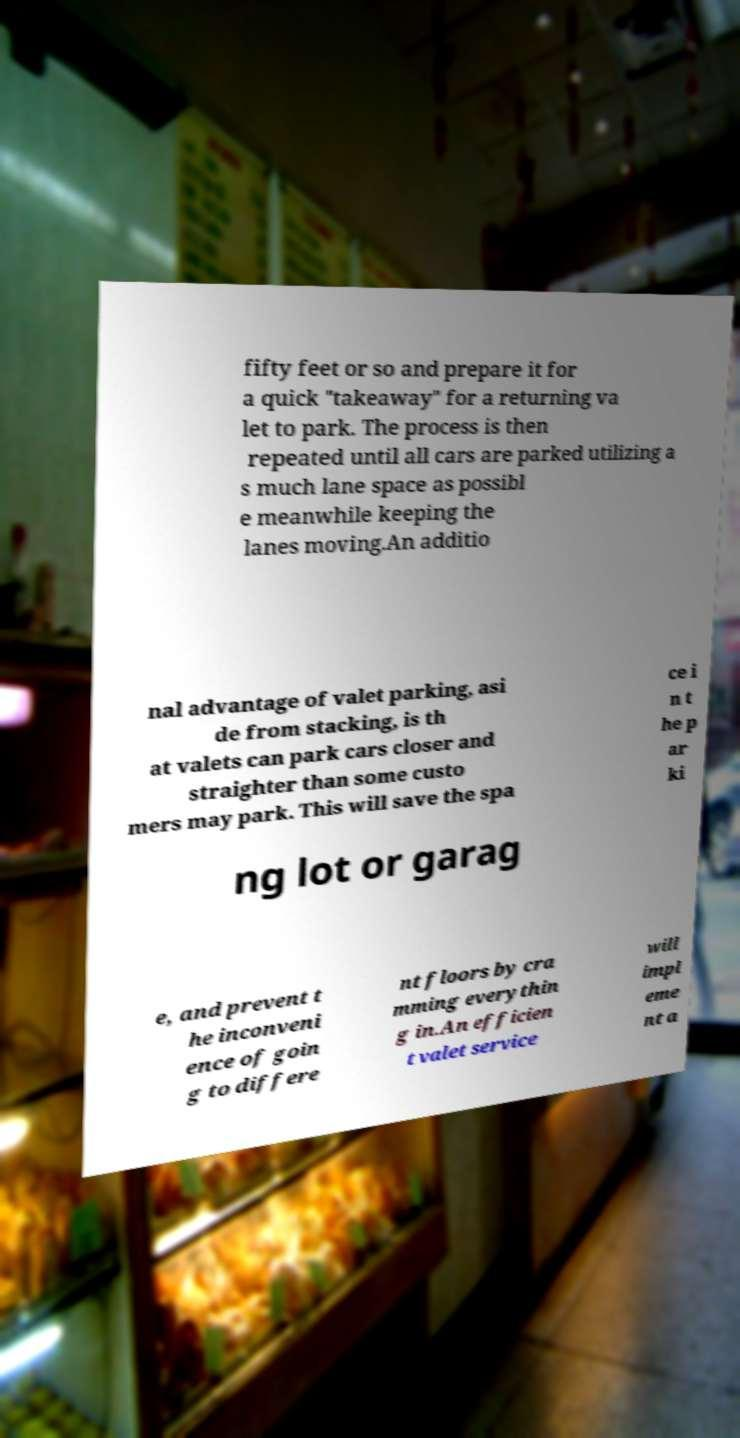Can you read and provide the text displayed in the image?This photo seems to have some interesting text. Can you extract and type it out for me? fifty feet or so and prepare it for a quick "takeaway" for a returning va let to park. The process is then repeated until all cars are parked utilizing a s much lane space as possibl e meanwhile keeping the lanes moving.An additio nal advantage of valet parking, asi de from stacking, is th at valets can park cars closer and straighter than some custo mers may park. This will save the spa ce i n t he p ar ki ng lot or garag e, and prevent t he inconveni ence of goin g to differe nt floors by cra mming everythin g in.An efficien t valet service will impl eme nt a 